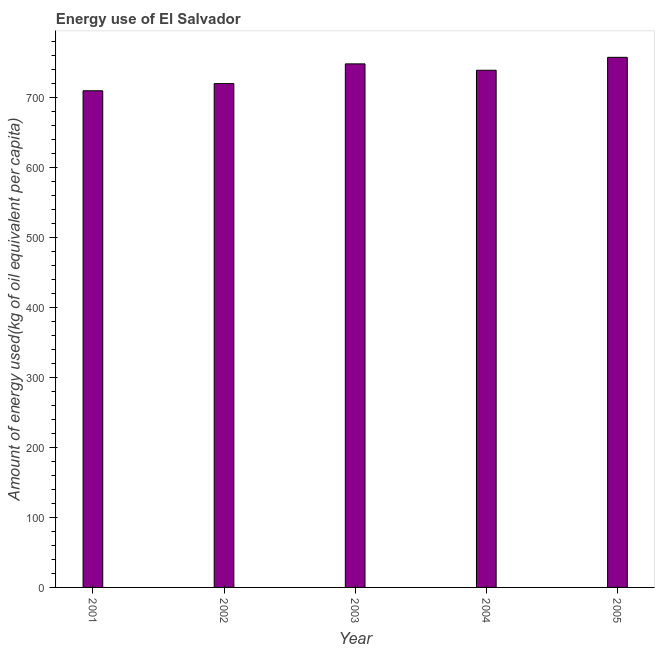Does the graph contain any zero values?
Provide a succinct answer. No. Does the graph contain grids?
Ensure brevity in your answer.  No. What is the title of the graph?
Provide a succinct answer. Energy use of El Salvador. What is the label or title of the X-axis?
Ensure brevity in your answer.  Year. What is the label or title of the Y-axis?
Provide a short and direct response. Amount of energy used(kg of oil equivalent per capita). What is the amount of energy used in 2001?
Ensure brevity in your answer.  710.12. Across all years, what is the maximum amount of energy used?
Give a very brief answer. 757.93. Across all years, what is the minimum amount of energy used?
Your answer should be compact. 710.12. What is the sum of the amount of energy used?
Offer a very short reply. 3676.43. What is the difference between the amount of energy used in 2001 and 2005?
Ensure brevity in your answer.  -47.82. What is the average amount of energy used per year?
Keep it short and to the point. 735.29. What is the median amount of energy used?
Your answer should be compact. 739.46. In how many years, is the amount of energy used greater than 600 kg?
Make the answer very short. 5. Is the amount of energy used in 2002 less than that in 2005?
Offer a terse response. Yes. What is the difference between the highest and the second highest amount of energy used?
Offer a very short reply. 9.37. What is the difference between the highest and the lowest amount of energy used?
Keep it short and to the point. 47.82. How many bars are there?
Offer a terse response. 5. What is the difference between two consecutive major ticks on the Y-axis?
Offer a very short reply. 100. What is the Amount of energy used(kg of oil equivalent per capita) in 2001?
Your response must be concise. 710.12. What is the Amount of energy used(kg of oil equivalent per capita) of 2002?
Keep it short and to the point. 720.35. What is the Amount of energy used(kg of oil equivalent per capita) of 2003?
Keep it short and to the point. 748.57. What is the Amount of energy used(kg of oil equivalent per capita) of 2004?
Your answer should be very brief. 739.46. What is the Amount of energy used(kg of oil equivalent per capita) in 2005?
Offer a very short reply. 757.93. What is the difference between the Amount of energy used(kg of oil equivalent per capita) in 2001 and 2002?
Make the answer very short. -10.24. What is the difference between the Amount of energy used(kg of oil equivalent per capita) in 2001 and 2003?
Provide a succinct answer. -38.45. What is the difference between the Amount of energy used(kg of oil equivalent per capita) in 2001 and 2004?
Give a very brief answer. -29.34. What is the difference between the Amount of energy used(kg of oil equivalent per capita) in 2001 and 2005?
Keep it short and to the point. -47.82. What is the difference between the Amount of energy used(kg of oil equivalent per capita) in 2002 and 2003?
Offer a very short reply. -28.21. What is the difference between the Amount of energy used(kg of oil equivalent per capita) in 2002 and 2004?
Provide a short and direct response. -19.11. What is the difference between the Amount of energy used(kg of oil equivalent per capita) in 2002 and 2005?
Provide a short and direct response. -37.58. What is the difference between the Amount of energy used(kg of oil equivalent per capita) in 2003 and 2004?
Offer a terse response. 9.11. What is the difference between the Amount of energy used(kg of oil equivalent per capita) in 2003 and 2005?
Give a very brief answer. -9.37. What is the difference between the Amount of energy used(kg of oil equivalent per capita) in 2004 and 2005?
Provide a succinct answer. -18.48. What is the ratio of the Amount of energy used(kg of oil equivalent per capita) in 2001 to that in 2003?
Give a very brief answer. 0.95. What is the ratio of the Amount of energy used(kg of oil equivalent per capita) in 2001 to that in 2005?
Your answer should be compact. 0.94. What is the ratio of the Amount of energy used(kg of oil equivalent per capita) in 2002 to that in 2003?
Ensure brevity in your answer.  0.96. What is the ratio of the Amount of energy used(kg of oil equivalent per capita) in 2002 to that in 2004?
Offer a very short reply. 0.97. What is the ratio of the Amount of energy used(kg of oil equivalent per capita) in 2003 to that in 2004?
Your response must be concise. 1.01. 